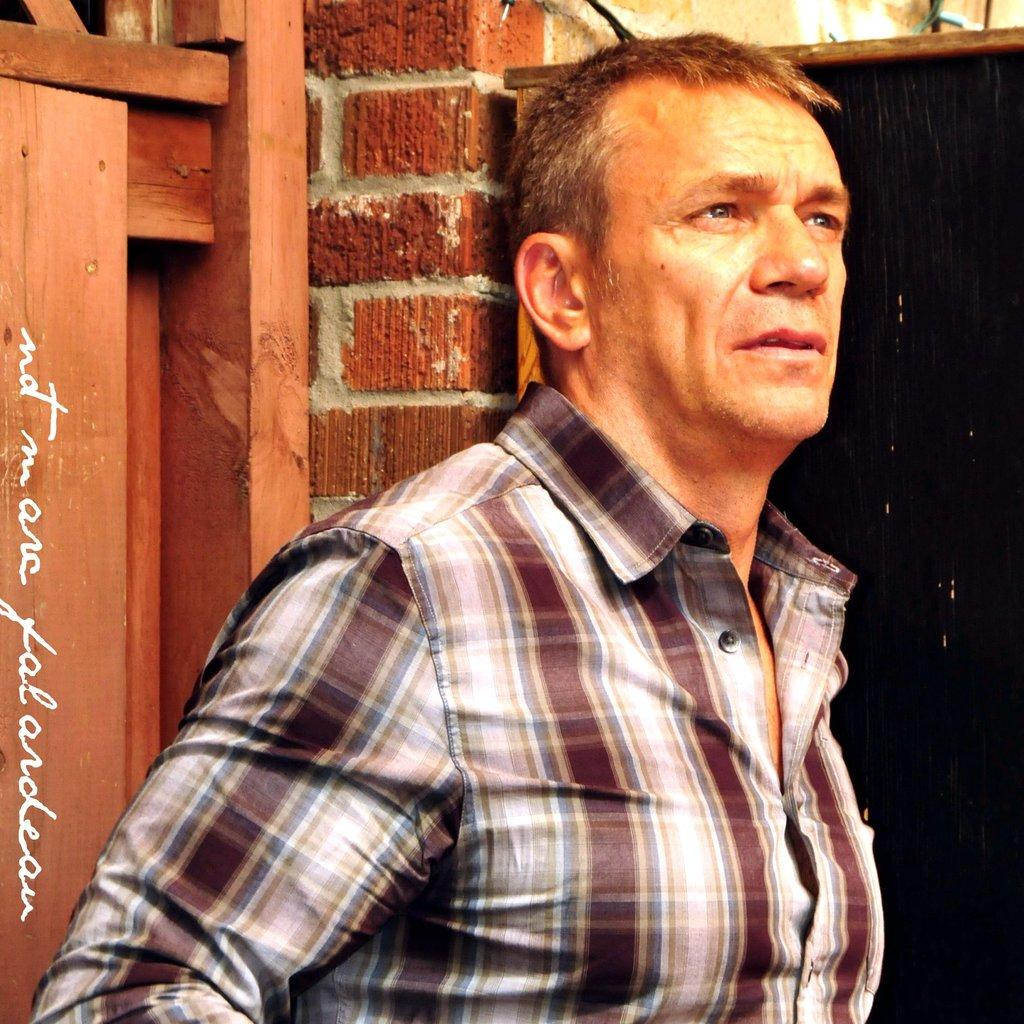What is the main subject of the image? There is a person in the image. Can you describe the person's position in relation to the surroundings? The person is standing beside a wall. How many apples are hanging from the bridge in the image? There is no bridge or apples present in the image. What is the person saying to the others as they say good-bye in the image? There is no indication of a good-bye or any conversation in the image. 